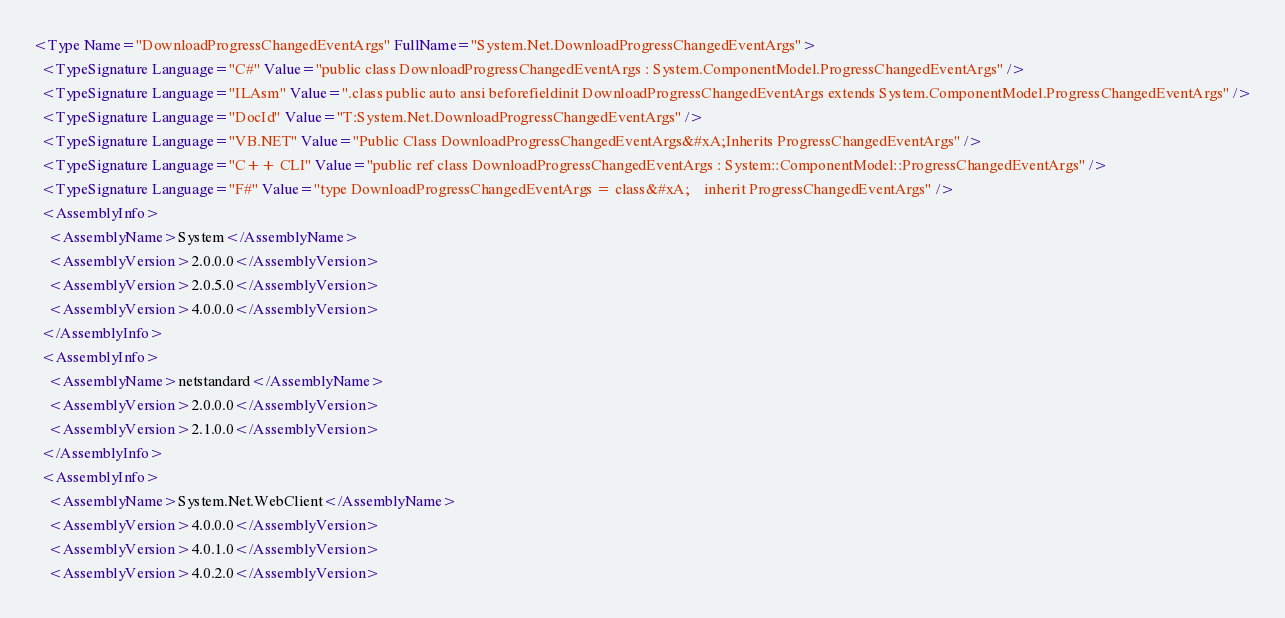<code> <loc_0><loc_0><loc_500><loc_500><_XML_><Type Name="DownloadProgressChangedEventArgs" FullName="System.Net.DownloadProgressChangedEventArgs">
  <TypeSignature Language="C#" Value="public class DownloadProgressChangedEventArgs : System.ComponentModel.ProgressChangedEventArgs" />
  <TypeSignature Language="ILAsm" Value=".class public auto ansi beforefieldinit DownloadProgressChangedEventArgs extends System.ComponentModel.ProgressChangedEventArgs" />
  <TypeSignature Language="DocId" Value="T:System.Net.DownloadProgressChangedEventArgs" />
  <TypeSignature Language="VB.NET" Value="Public Class DownloadProgressChangedEventArgs&#xA;Inherits ProgressChangedEventArgs" />
  <TypeSignature Language="C++ CLI" Value="public ref class DownloadProgressChangedEventArgs : System::ComponentModel::ProgressChangedEventArgs" />
  <TypeSignature Language="F#" Value="type DownloadProgressChangedEventArgs = class&#xA;    inherit ProgressChangedEventArgs" />
  <AssemblyInfo>
    <AssemblyName>System</AssemblyName>
    <AssemblyVersion>2.0.0.0</AssemblyVersion>
    <AssemblyVersion>2.0.5.0</AssemblyVersion>
    <AssemblyVersion>4.0.0.0</AssemblyVersion>
  </AssemblyInfo>
  <AssemblyInfo>
    <AssemblyName>netstandard</AssemblyName>
    <AssemblyVersion>2.0.0.0</AssemblyVersion>
    <AssemblyVersion>2.1.0.0</AssemblyVersion>
  </AssemblyInfo>
  <AssemblyInfo>
    <AssemblyName>System.Net.WebClient</AssemblyName>
    <AssemblyVersion>4.0.0.0</AssemblyVersion>
    <AssemblyVersion>4.0.1.0</AssemblyVersion>
    <AssemblyVersion>4.0.2.0</AssemblyVersion></code> 